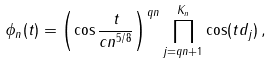Convert formula to latex. <formula><loc_0><loc_0><loc_500><loc_500>\phi _ { n } ( t ) = \left ( \cos \frac { t } { c n ^ { 5 / 8 } } \right ) ^ { q n } \prod _ { j = q n + 1 } ^ { K _ { n } } \cos ( t d _ { j } ) \, ,</formula> 